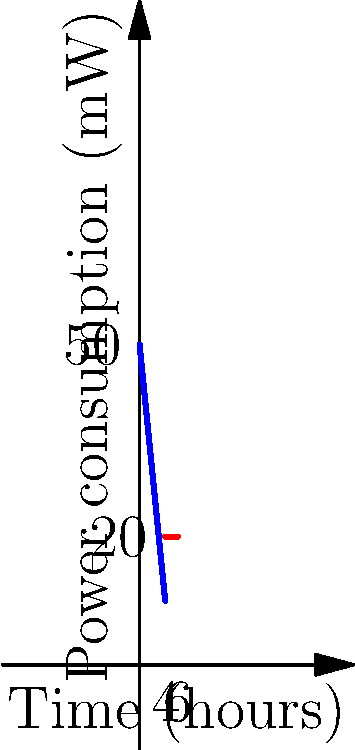A pair of wireless earbuds used during workouts has a 200 mWh battery. The power consumption graph shows the device's energy usage over time. During the first 4 hours (workout mode), the power consumption decreases linearly from 50 mW to 20 mW. After 4 hours, it remains constant at 20 mW (standby mode). How long will the battery last before it needs recharging? To solve this problem, we need to calculate the total energy consumed and compare it to the battery capacity. Let's break it down step-by-step:

1. Calculate the energy consumed during workout mode (0-4 hours):
   - The power consumption follows a linear decrease from 50 mW to 20 mW over 4 hours.
   - Average power consumption = $\frac{50 + 20}{2} = 35$ mW
   - Energy consumed = 35 mW × 4 h = 140 mWh

2. Calculate the remaining battery capacity after workout mode:
   - Remaining capacity = 200 mWh - 140 mWh = 60 mWh

3. Calculate how long the remaining capacity will last in standby mode:
   - Standby power consumption = 20 mW
   - Time in standby mode = $\frac{60 \text{ mWh}}{20 \text{ mW}} = 3$ h

4. Sum up the total battery life:
   - Total time = Workout mode + Standby mode
   - Total time = 4 h + 3 h = 7 h

Therefore, the battery will last for 7 hours before needing to be recharged.
Answer: 7 hours 